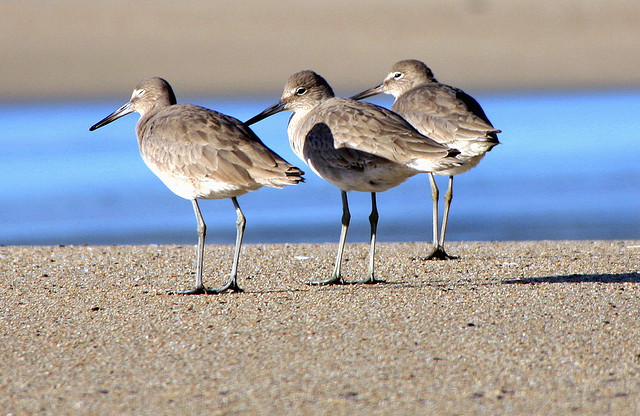<image>What kind of birds are these? I am not sure what kind of birds these are. They could be pelicans, sandpipers, seagulls, finch, sea birds, starks, or pigeons. What kind of birds are these? I am not sure what kind of birds are these. It can be pelicans, sandpipers, seagulls, or pigeons. 